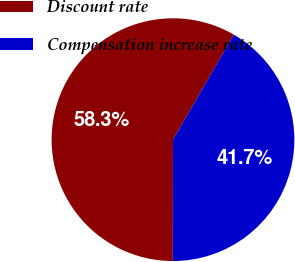Convert chart to OTSL. <chart><loc_0><loc_0><loc_500><loc_500><pie_chart><fcel>Discount rate<fcel>Compensation increase rate<nl><fcel>58.33%<fcel>41.67%<nl></chart> 